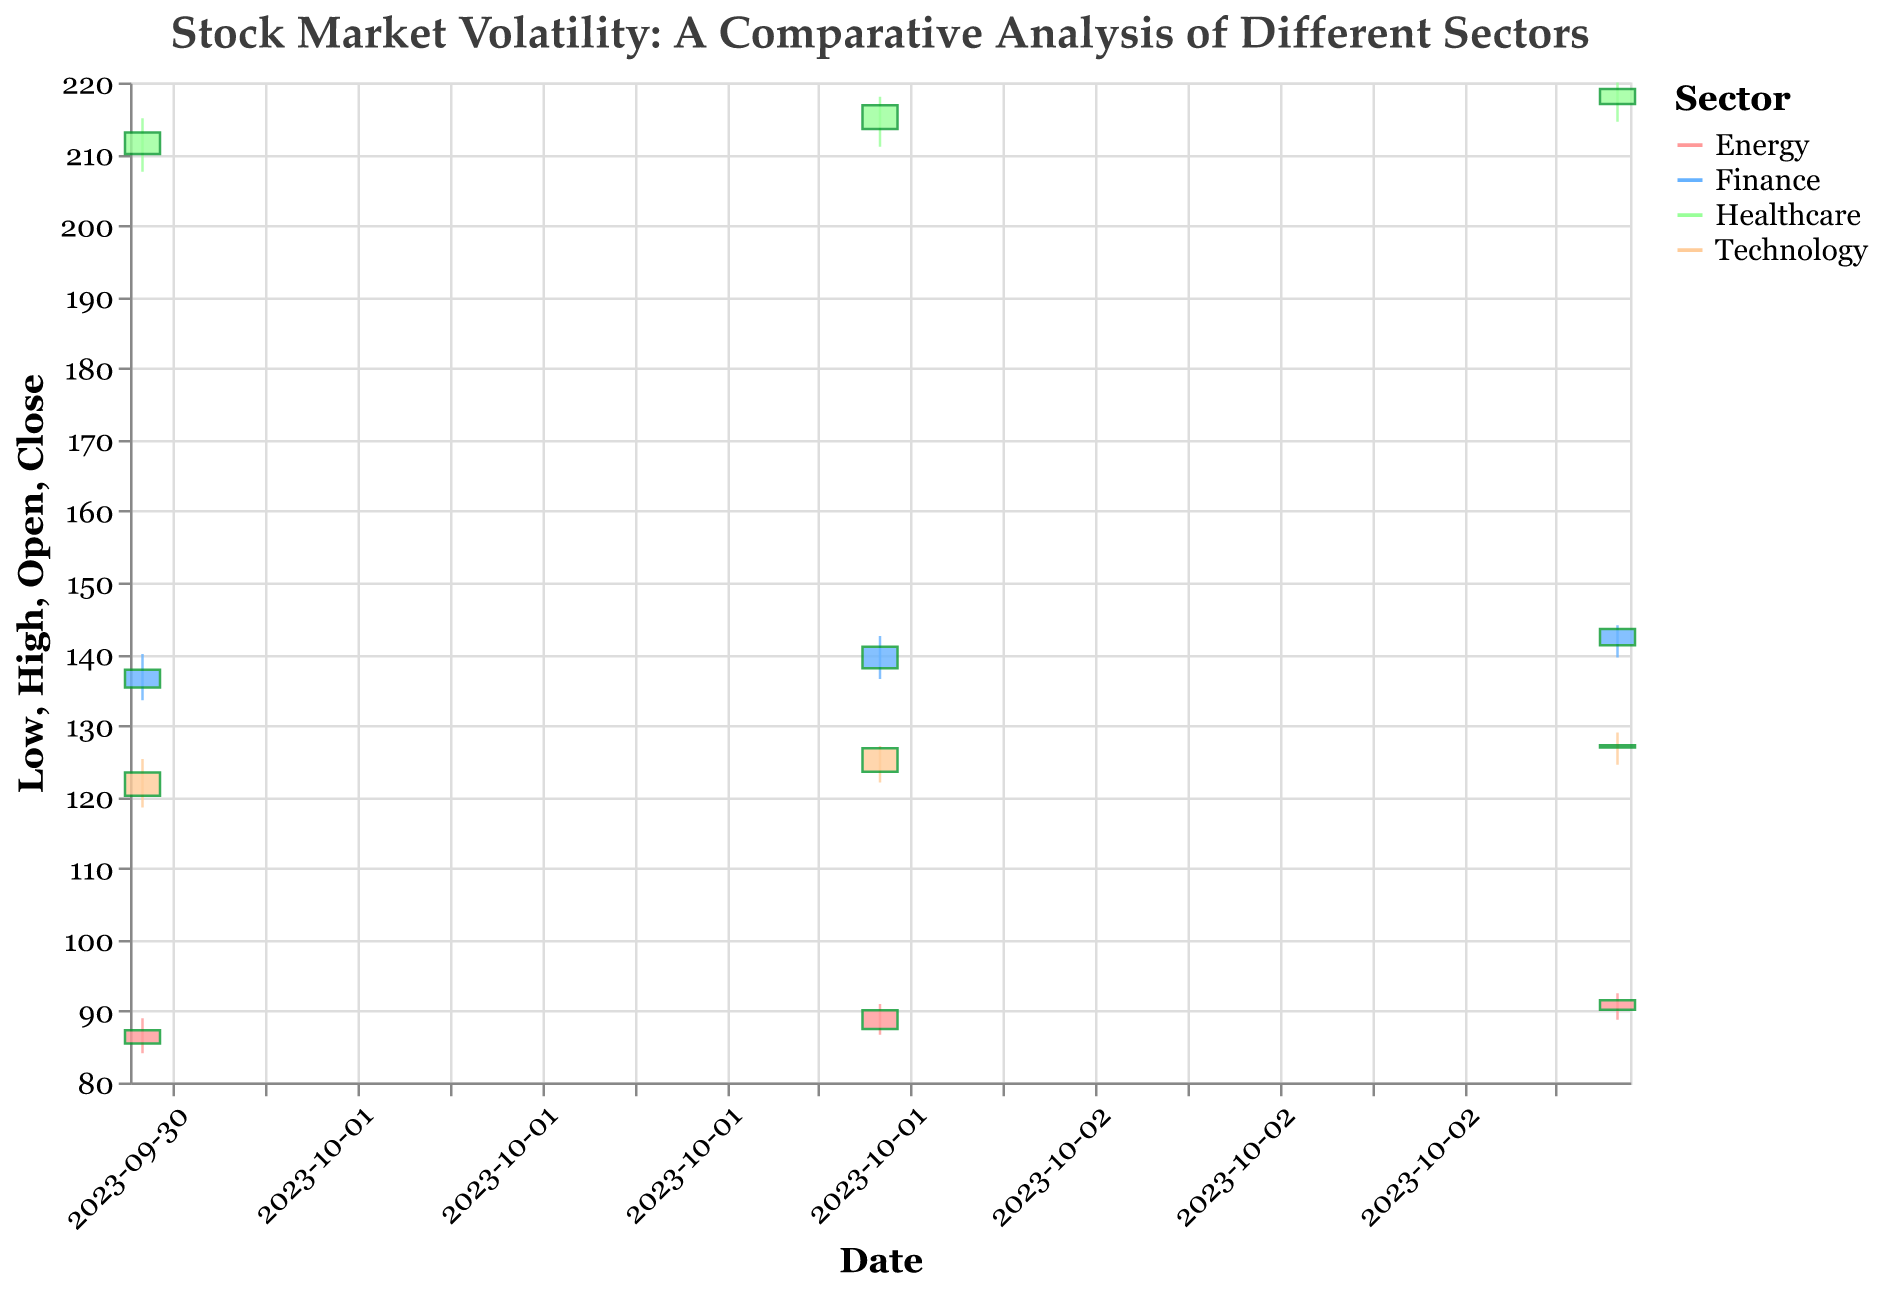Which sector shows the highest variability in stock prices over the given dates? To determine the sector with the highest variability in stock prices, compare the difference between the high and low prices for each stock across the given dates. Compare these differences for each sector: Technology (Apple), Energy (ExxonMobil), Healthcare (Johnson & Johnson), and Finance (JPMorgan Chase). Notice that Energy (ExxonMobil) has the highest difference between the high and low prices, indicating the most variability.
Answer: Energy On 2023-10-02, which stock had the highest closing price? Check the closing prices for each stock on 2023-10-02: Apple (126.80), ExxonMobil (90.10), Johnson & Johnson (216.80), and JPMorgan Chase (141.00). Johnson & Johnson has the highest closing price on this date.
Answer: Johnson & Johnson Which sector had the lowest trading volume on 2023-10-01? Refer to the trading volumes for each sector on 2023-10-01. Technology (Apple) had 5500000, Energy (ExxonMobil) had 7200000, Healthcare (Johnson & Johnson) had 4300000, and Finance (JPMorgan Chase) had 5200000. Healthcare (Johnson & Johnson) had the lowest trading volume.
Answer: Healthcare How did the stock price of Apple change from 2023-10-01 to 2023-10-03? Calculate the difference between the closing price on 2023-10-03 (127.20) and the closing price on 2023-10-01 (123.40). The change in stock price is 127.20 - 123.40 = 3.80. Apple's stock price increased by 3.80.
Answer: Increased by 3.80 Compare the stock price performance of ExxonMobil and JPMorgan Chase on 2023-10-03. Which one performed better in terms of closing price? Check the closing prices on 2023-10-03 for both ExxonMobil (91.50) and JPMorgan Chase (143.50). JPMorgan Chase has a higher closing price, indicating better performance.
Answer: JPMorgan Chase What was the average closing price for Johnson & Johnson over the three-day period? Add the closing prices for Johnson & Johnson over the three days (213.00, 216.80, 219.10) and divide by the number of days (3). The sum is 648.90, and the average is 648.90 / 3 = 216.30.
Answer: 216.30 Which stock had the highest increase in trading volume from 2023-10-02 to 2023-10-03? Calculate the differences in trading volumes for each stock: Apple increased by 500000, ExxonMobil increased by 200000, Johnson & Johnson increased by 300000, and JPMorgan Chase increased by 200000. Apple had the highest increase in trading volume.
Answer: Apple What can be inferred about the overall trend for the finance sector based on the closing prices of JPMorgan Chase during this period? Observe the closing prices for JPMorgan Chase: 137.80 on 2023-10-01, 141.00 on 2023-10-02, and 143.50 on 2023-10-03. The consistent increase in closing prices over the three days indicates an upward trend for the finance sector.
Answer: Upward trend On which date did Johnson & Johnson experience the smallest difference between its high and low prices? Calculate the differences between high and low prices for Johnson & Johnson: (215.00 - 207.50) = 7.50 on 2023-10-01, (218.00 - 211.00) = 7.00 on 2023-10-02, and (220.00 - 214.50) = 5.50 on 2023-10-03. The smallest difference was on 2023-10-03.
Answer: 2023-10-03 